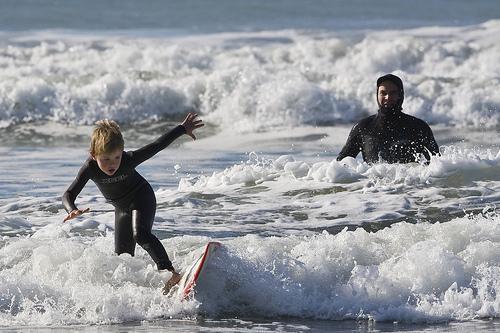How many men are there?
Give a very brief answer. 1. How many boys are there?
Give a very brief answer. 1. 